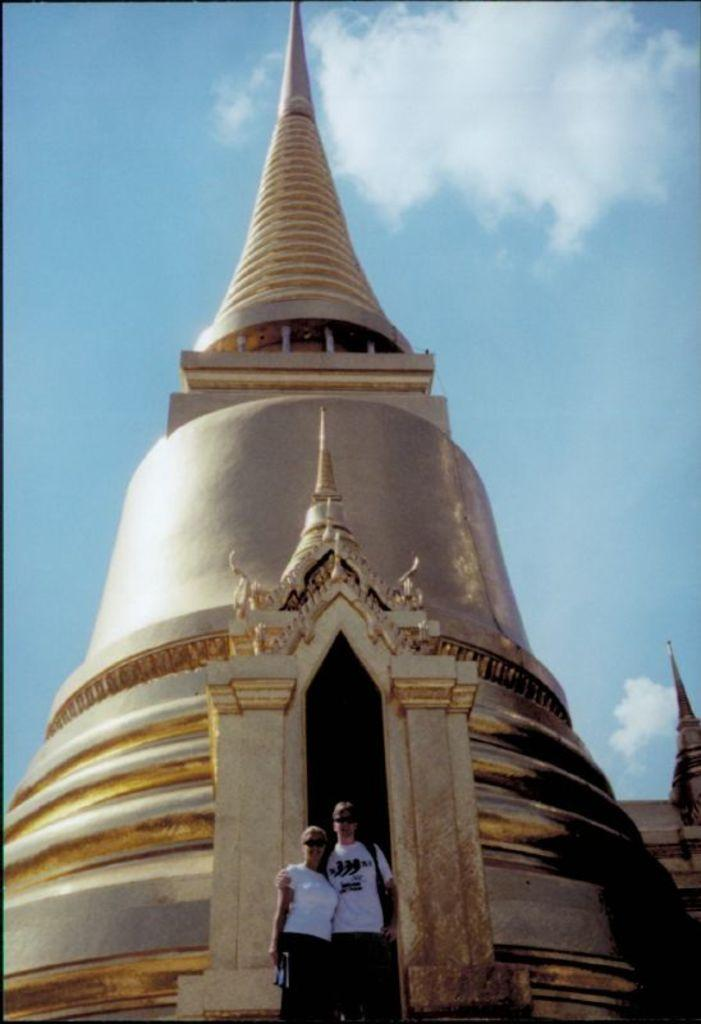How many people are present in the image? There are two persons standing in the image. What can be seen in the background of the image? There is an architecture visible in the background, and the sky is also visible. What type of comb is being used by one of the persons in the image? There is no comb present in the image. Where is the faucet located in the image? There is no faucet present in the image. 